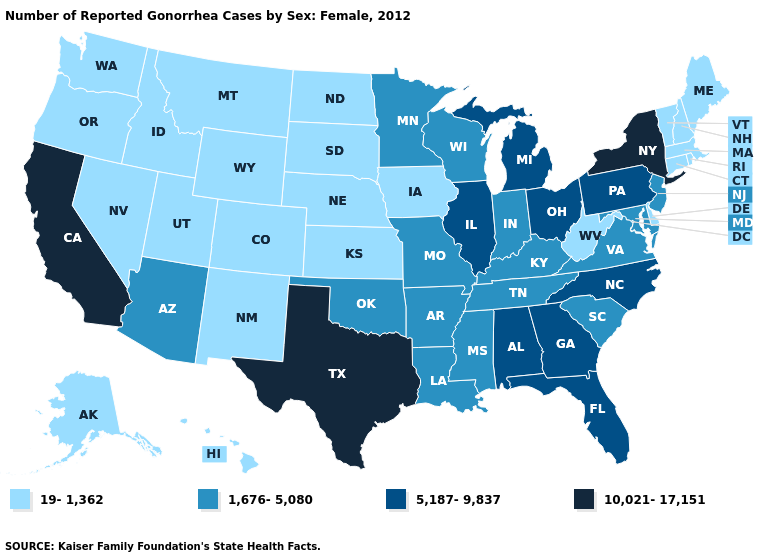Name the states that have a value in the range 1,676-5,080?
Quick response, please. Arizona, Arkansas, Indiana, Kentucky, Louisiana, Maryland, Minnesota, Mississippi, Missouri, New Jersey, Oklahoma, South Carolina, Tennessee, Virginia, Wisconsin. Does New York have the highest value in the USA?
Answer briefly. Yes. Does Illinois have the highest value in the MidWest?
Answer briefly. Yes. Name the states that have a value in the range 5,187-9,837?
Concise answer only. Alabama, Florida, Georgia, Illinois, Michigan, North Carolina, Ohio, Pennsylvania. Name the states that have a value in the range 1,676-5,080?
Keep it brief. Arizona, Arkansas, Indiana, Kentucky, Louisiana, Maryland, Minnesota, Mississippi, Missouri, New Jersey, Oklahoma, South Carolina, Tennessee, Virginia, Wisconsin. What is the value of Alaska?
Write a very short answer. 19-1,362. What is the highest value in states that border Idaho?
Short answer required. 19-1,362. Which states hav the highest value in the MidWest?
Quick response, please. Illinois, Michigan, Ohio. Which states have the highest value in the USA?
Quick response, please. California, New York, Texas. Name the states that have a value in the range 10,021-17,151?
Keep it brief. California, New York, Texas. What is the highest value in the West ?
Concise answer only. 10,021-17,151. Name the states that have a value in the range 19-1,362?
Concise answer only. Alaska, Colorado, Connecticut, Delaware, Hawaii, Idaho, Iowa, Kansas, Maine, Massachusetts, Montana, Nebraska, Nevada, New Hampshire, New Mexico, North Dakota, Oregon, Rhode Island, South Dakota, Utah, Vermont, Washington, West Virginia, Wyoming. What is the value of Pennsylvania?
Give a very brief answer. 5,187-9,837. Name the states that have a value in the range 5,187-9,837?
Short answer required. Alabama, Florida, Georgia, Illinois, Michigan, North Carolina, Ohio, Pennsylvania. 